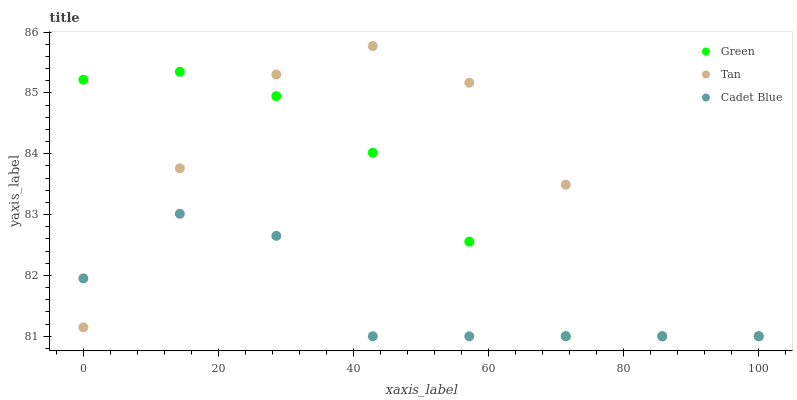Does Cadet Blue have the minimum area under the curve?
Answer yes or no. Yes. Does Tan have the maximum area under the curve?
Answer yes or no. Yes. Does Green have the minimum area under the curve?
Answer yes or no. No. Does Green have the maximum area under the curve?
Answer yes or no. No. Is Green the smoothest?
Answer yes or no. Yes. Is Tan the roughest?
Answer yes or no. Yes. Is Cadet Blue the smoothest?
Answer yes or no. No. Is Cadet Blue the roughest?
Answer yes or no. No. Does Tan have the lowest value?
Answer yes or no. Yes. Does Tan have the highest value?
Answer yes or no. Yes. Does Green have the highest value?
Answer yes or no. No. Does Tan intersect Green?
Answer yes or no. Yes. Is Tan less than Green?
Answer yes or no. No. Is Tan greater than Green?
Answer yes or no. No. 